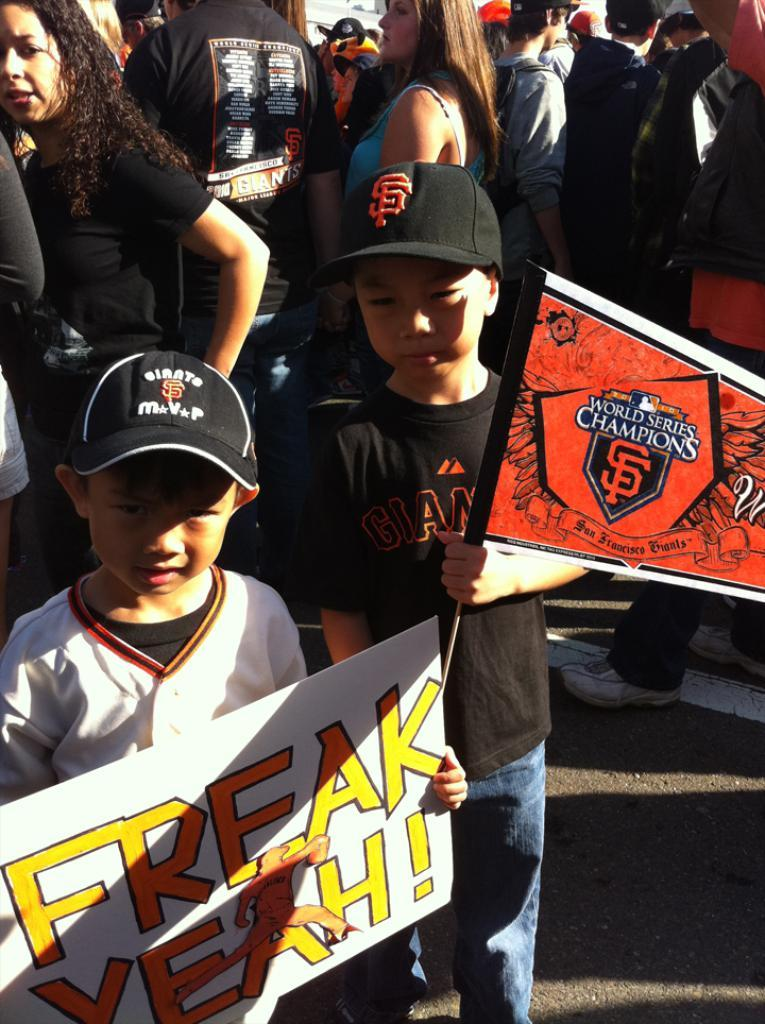<image>
Relay a brief, clear account of the picture shown. Two little boys hold a flag and a sign that says freak yeah! 